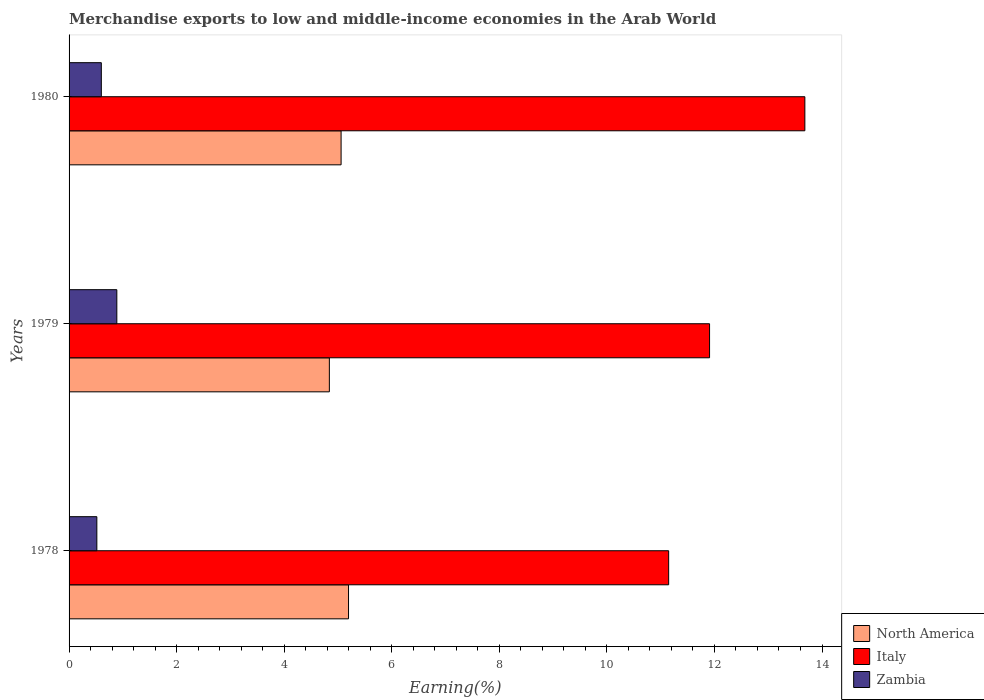How many different coloured bars are there?
Give a very brief answer. 3. How many groups of bars are there?
Ensure brevity in your answer.  3. Are the number of bars per tick equal to the number of legend labels?
Keep it short and to the point. Yes. How many bars are there on the 1st tick from the top?
Ensure brevity in your answer.  3. How many bars are there on the 2nd tick from the bottom?
Keep it short and to the point. 3. What is the percentage of amount earned from merchandise exports in Italy in 1978?
Offer a very short reply. 11.15. Across all years, what is the maximum percentage of amount earned from merchandise exports in Italy?
Offer a very short reply. 13.68. Across all years, what is the minimum percentage of amount earned from merchandise exports in Italy?
Keep it short and to the point. 11.15. In which year was the percentage of amount earned from merchandise exports in Zambia maximum?
Make the answer very short. 1979. In which year was the percentage of amount earned from merchandise exports in North America minimum?
Provide a short and direct response. 1979. What is the total percentage of amount earned from merchandise exports in Italy in the graph?
Your answer should be very brief. 36.74. What is the difference between the percentage of amount earned from merchandise exports in North America in 1979 and that in 1980?
Give a very brief answer. -0.22. What is the difference between the percentage of amount earned from merchandise exports in Zambia in 1980 and the percentage of amount earned from merchandise exports in North America in 1979?
Provide a succinct answer. -4.24. What is the average percentage of amount earned from merchandise exports in North America per year?
Give a very brief answer. 5.03. In the year 1979, what is the difference between the percentage of amount earned from merchandise exports in Zambia and percentage of amount earned from merchandise exports in Italy?
Offer a terse response. -11.02. What is the ratio of the percentage of amount earned from merchandise exports in North America in 1978 to that in 1979?
Provide a succinct answer. 1.07. Is the percentage of amount earned from merchandise exports in Zambia in 1978 less than that in 1979?
Offer a very short reply. Yes. What is the difference between the highest and the second highest percentage of amount earned from merchandise exports in North America?
Keep it short and to the point. 0.14. What is the difference between the highest and the lowest percentage of amount earned from merchandise exports in Italy?
Provide a succinct answer. 2.53. In how many years, is the percentage of amount earned from merchandise exports in Italy greater than the average percentage of amount earned from merchandise exports in Italy taken over all years?
Make the answer very short. 1. Is the sum of the percentage of amount earned from merchandise exports in North America in 1978 and 1979 greater than the maximum percentage of amount earned from merchandise exports in Italy across all years?
Provide a succinct answer. No. Is it the case that in every year, the sum of the percentage of amount earned from merchandise exports in Zambia and percentage of amount earned from merchandise exports in Italy is greater than the percentage of amount earned from merchandise exports in North America?
Offer a very short reply. Yes. How many bars are there?
Offer a terse response. 9. Are all the bars in the graph horizontal?
Offer a very short reply. Yes. What is the difference between two consecutive major ticks on the X-axis?
Offer a terse response. 2. Are the values on the major ticks of X-axis written in scientific E-notation?
Offer a terse response. No. Does the graph contain any zero values?
Your response must be concise. No. Does the graph contain grids?
Your response must be concise. No. How are the legend labels stacked?
Offer a very short reply. Vertical. What is the title of the graph?
Your response must be concise. Merchandise exports to low and middle-income economies in the Arab World. What is the label or title of the X-axis?
Ensure brevity in your answer.  Earning(%). What is the label or title of the Y-axis?
Your answer should be compact. Years. What is the Earning(%) in North America in 1978?
Make the answer very short. 5.2. What is the Earning(%) of Italy in 1978?
Provide a succinct answer. 11.15. What is the Earning(%) of Zambia in 1978?
Provide a succinct answer. 0.52. What is the Earning(%) of North America in 1979?
Provide a short and direct response. 4.84. What is the Earning(%) in Italy in 1979?
Your response must be concise. 11.91. What is the Earning(%) of Zambia in 1979?
Offer a terse response. 0.89. What is the Earning(%) of North America in 1980?
Offer a terse response. 5.06. What is the Earning(%) in Italy in 1980?
Your response must be concise. 13.68. What is the Earning(%) of Zambia in 1980?
Ensure brevity in your answer.  0.6. Across all years, what is the maximum Earning(%) in North America?
Provide a short and direct response. 5.2. Across all years, what is the maximum Earning(%) of Italy?
Provide a short and direct response. 13.68. Across all years, what is the maximum Earning(%) in Zambia?
Offer a terse response. 0.89. Across all years, what is the minimum Earning(%) of North America?
Keep it short and to the point. 4.84. Across all years, what is the minimum Earning(%) in Italy?
Keep it short and to the point. 11.15. Across all years, what is the minimum Earning(%) in Zambia?
Your answer should be very brief. 0.52. What is the total Earning(%) in North America in the graph?
Provide a short and direct response. 15.09. What is the total Earning(%) of Italy in the graph?
Offer a terse response. 36.74. What is the total Earning(%) in Zambia in the graph?
Your answer should be compact. 2. What is the difference between the Earning(%) in North America in 1978 and that in 1979?
Provide a succinct answer. 0.36. What is the difference between the Earning(%) of Italy in 1978 and that in 1979?
Offer a terse response. -0.76. What is the difference between the Earning(%) of Zambia in 1978 and that in 1979?
Make the answer very short. -0.37. What is the difference between the Earning(%) of North America in 1978 and that in 1980?
Make the answer very short. 0.14. What is the difference between the Earning(%) in Italy in 1978 and that in 1980?
Your response must be concise. -2.53. What is the difference between the Earning(%) of Zambia in 1978 and that in 1980?
Offer a terse response. -0.08. What is the difference between the Earning(%) in North America in 1979 and that in 1980?
Ensure brevity in your answer.  -0.22. What is the difference between the Earning(%) of Italy in 1979 and that in 1980?
Provide a short and direct response. -1.77. What is the difference between the Earning(%) of Zambia in 1979 and that in 1980?
Make the answer very short. 0.29. What is the difference between the Earning(%) in North America in 1978 and the Earning(%) in Italy in 1979?
Make the answer very short. -6.71. What is the difference between the Earning(%) of North America in 1978 and the Earning(%) of Zambia in 1979?
Your response must be concise. 4.31. What is the difference between the Earning(%) of Italy in 1978 and the Earning(%) of Zambia in 1979?
Your answer should be compact. 10.26. What is the difference between the Earning(%) of North America in 1978 and the Earning(%) of Italy in 1980?
Your response must be concise. -8.48. What is the difference between the Earning(%) in North America in 1978 and the Earning(%) in Zambia in 1980?
Provide a succinct answer. 4.6. What is the difference between the Earning(%) of Italy in 1978 and the Earning(%) of Zambia in 1980?
Provide a short and direct response. 10.55. What is the difference between the Earning(%) of North America in 1979 and the Earning(%) of Italy in 1980?
Offer a very short reply. -8.84. What is the difference between the Earning(%) in North America in 1979 and the Earning(%) in Zambia in 1980?
Your answer should be compact. 4.24. What is the difference between the Earning(%) in Italy in 1979 and the Earning(%) in Zambia in 1980?
Ensure brevity in your answer.  11.31. What is the average Earning(%) of North America per year?
Your answer should be compact. 5.03. What is the average Earning(%) in Italy per year?
Your answer should be compact. 12.25. What is the average Earning(%) of Zambia per year?
Offer a very short reply. 0.67. In the year 1978, what is the difference between the Earning(%) of North America and Earning(%) of Italy?
Give a very brief answer. -5.95. In the year 1978, what is the difference between the Earning(%) of North America and Earning(%) of Zambia?
Provide a succinct answer. 4.68. In the year 1978, what is the difference between the Earning(%) in Italy and Earning(%) in Zambia?
Your answer should be very brief. 10.63. In the year 1979, what is the difference between the Earning(%) of North America and Earning(%) of Italy?
Your answer should be compact. -7.07. In the year 1979, what is the difference between the Earning(%) in North America and Earning(%) in Zambia?
Ensure brevity in your answer.  3.95. In the year 1979, what is the difference between the Earning(%) in Italy and Earning(%) in Zambia?
Offer a very short reply. 11.02. In the year 1980, what is the difference between the Earning(%) in North America and Earning(%) in Italy?
Keep it short and to the point. -8.62. In the year 1980, what is the difference between the Earning(%) of North America and Earning(%) of Zambia?
Your answer should be very brief. 4.46. In the year 1980, what is the difference between the Earning(%) in Italy and Earning(%) in Zambia?
Make the answer very short. 13.08. What is the ratio of the Earning(%) of North America in 1978 to that in 1979?
Keep it short and to the point. 1.07. What is the ratio of the Earning(%) in Italy in 1978 to that in 1979?
Ensure brevity in your answer.  0.94. What is the ratio of the Earning(%) of Zambia in 1978 to that in 1979?
Ensure brevity in your answer.  0.58. What is the ratio of the Earning(%) of North America in 1978 to that in 1980?
Offer a terse response. 1.03. What is the ratio of the Earning(%) in Italy in 1978 to that in 1980?
Give a very brief answer. 0.81. What is the ratio of the Earning(%) of Zambia in 1978 to that in 1980?
Give a very brief answer. 0.86. What is the ratio of the Earning(%) of North America in 1979 to that in 1980?
Offer a very short reply. 0.96. What is the ratio of the Earning(%) of Italy in 1979 to that in 1980?
Give a very brief answer. 0.87. What is the ratio of the Earning(%) of Zambia in 1979 to that in 1980?
Your answer should be compact. 1.48. What is the difference between the highest and the second highest Earning(%) in North America?
Keep it short and to the point. 0.14. What is the difference between the highest and the second highest Earning(%) of Italy?
Provide a succinct answer. 1.77. What is the difference between the highest and the second highest Earning(%) in Zambia?
Provide a succinct answer. 0.29. What is the difference between the highest and the lowest Earning(%) of North America?
Provide a succinct answer. 0.36. What is the difference between the highest and the lowest Earning(%) in Italy?
Make the answer very short. 2.53. What is the difference between the highest and the lowest Earning(%) of Zambia?
Keep it short and to the point. 0.37. 